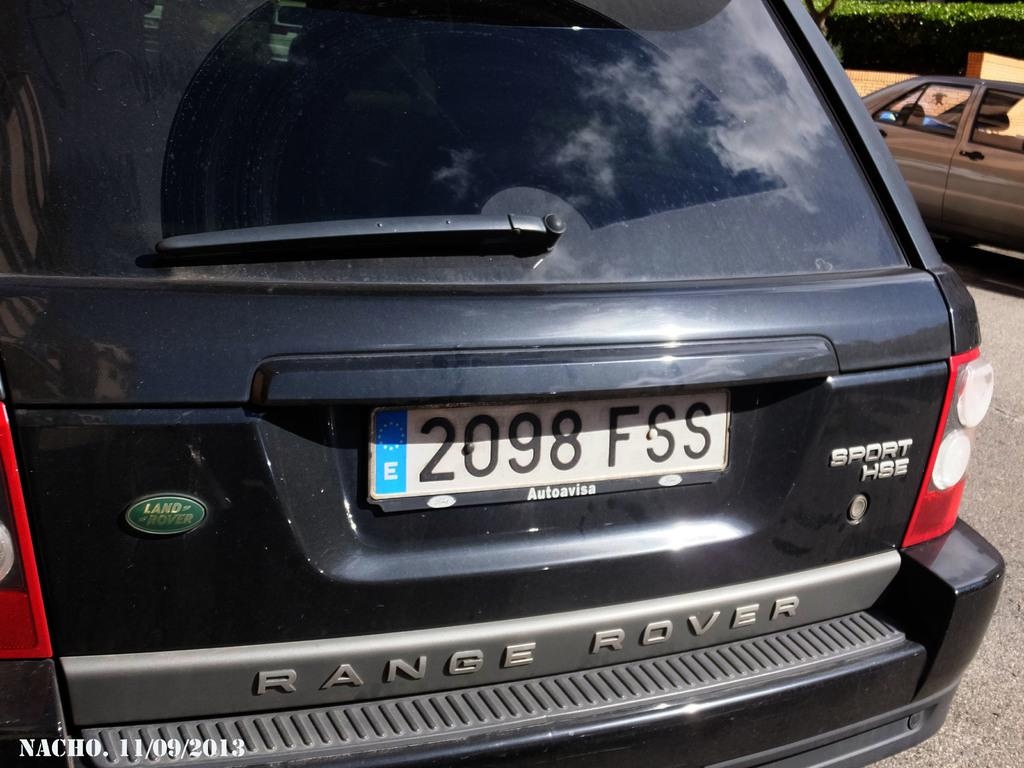<image>
Provide a brief description of the given image. Black Range Rover with a license plate which says 2098FSS. 